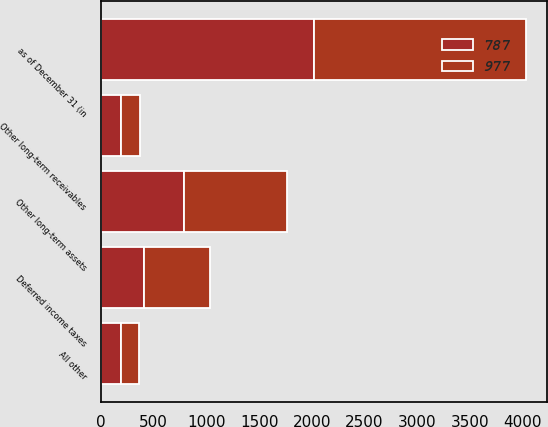Convert chart to OTSL. <chart><loc_0><loc_0><loc_500><loc_500><stacked_bar_chart><ecel><fcel>as of December 31 (in<fcel>Deferred income taxes<fcel>Other long-term receivables<fcel>All other<fcel>Other long-term assets<nl><fcel>787<fcel>2017<fcel>408<fcel>187<fcel>192<fcel>787<nl><fcel>977<fcel>2016<fcel>629<fcel>181<fcel>167<fcel>977<nl></chart> 